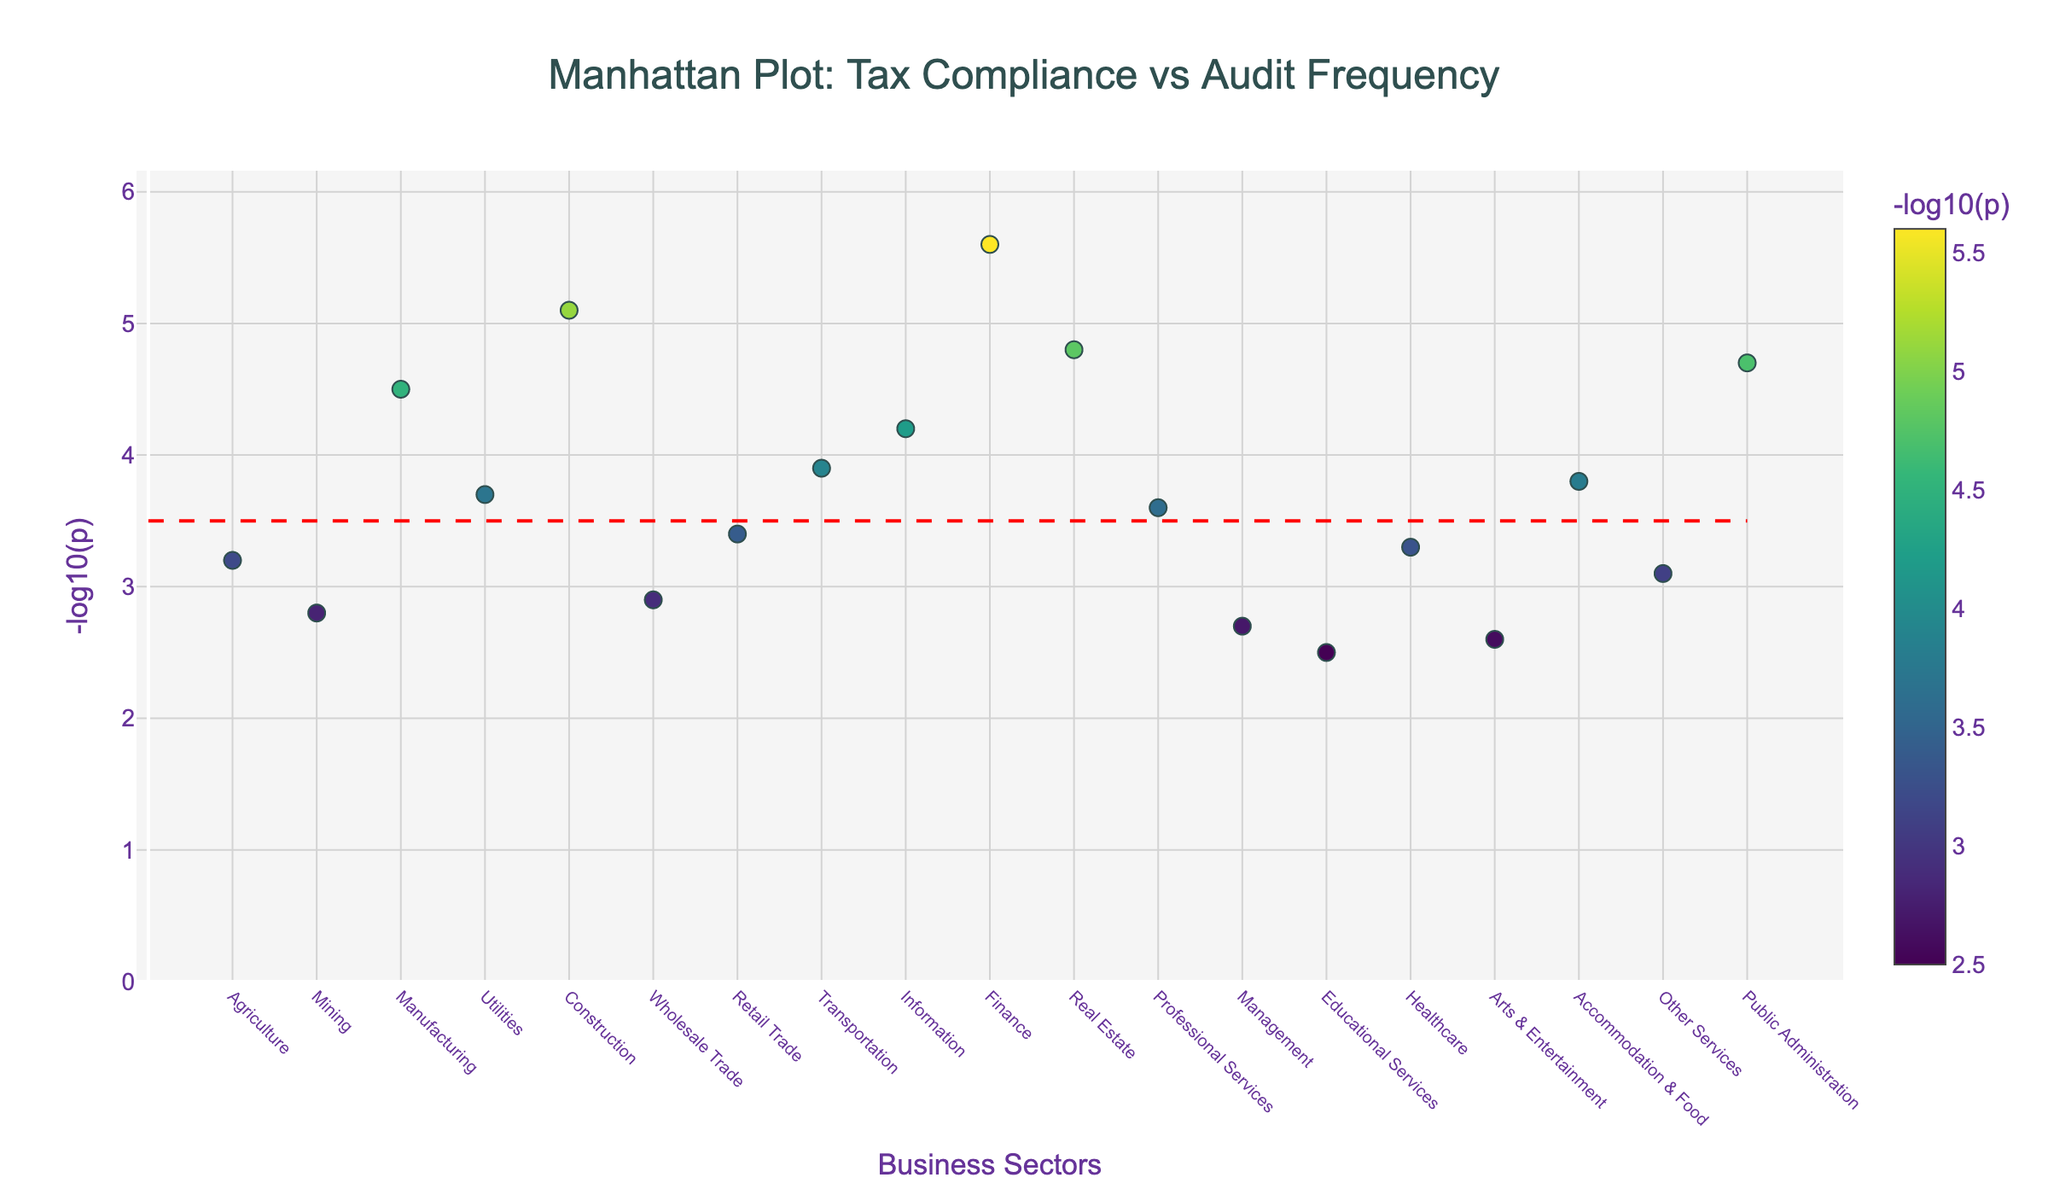What's the title of the figure? The title can be found at the top of the figure.
Answer: Manhattan Plot: Tax Compliance vs Audit Frequency How many business sectors are represented in this plot? Each business sector is represented by one data point on the x-axis.
Answer: 19 What does the y-axis represent? The y-axis label indicates the representation.
Answer: -log10(p) Which sector has the highest value of -log10(p)? Locate the highest y-axis value and identify the corresponding sector by checking the hover information or x-axis label.
Answer: Finance Are there any sectors below the threshold line of -log10(p) = 3.5? Identify any data points that fall below the red dashed line at y = 3.5.
Answer: Yes What sector has the lowest value of -log10(p)? Locate the lowest y-axis value and identify the corresponding sector by checking the hover information or x-axis label.
Answer: Educational Services How many sectors have a -log10(p) value greater than the threshold of 3.5? Count the data points above the red dashed line at y = 3.5.
Answer: 12 What is the average value of -log10(p) across all sectors? Sum all -log10(p) values and divide by the number of sectors (19).
Answer: 3.753 Which sector has a -log10(p) value closest to the median of all sectors? Median is the middle value when -log10(p) values are sorted in ascending order. Identify the sector for the median position.
Answer: Healthcare What is the difference in -log10(p) values between the Manufacturing and Real Estate sectors? Subtract the -log10(p) value of Manufacturing from Real Estate.
Answer: 0.3 